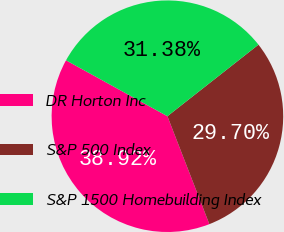Convert chart. <chart><loc_0><loc_0><loc_500><loc_500><pie_chart><fcel>DR Horton Inc<fcel>S&P 500 Index<fcel>S&P 1500 Homebuilding Index<nl><fcel>38.92%<fcel>29.7%<fcel>31.38%<nl></chart> 